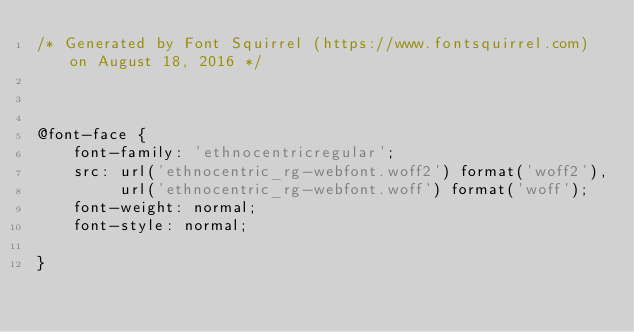<code> <loc_0><loc_0><loc_500><loc_500><_CSS_>/* Generated by Font Squirrel (https://www.fontsquirrel.com) on August 18, 2016 */



@font-face {
    font-family: 'ethnocentricregular';
    src: url('ethnocentric_rg-webfont.woff2') format('woff2'),
         url('ethnocentric_rg-webfont.woff') format('woff');
    font-weight: normal;
    font-style: normal;

}</code> 